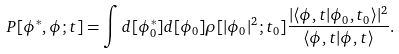<formula> <loc_0><loc_0><loc_500><loc_500>P [ \phi ^ { * } , \phi ; t ] = \int d [ \phi _ { 0 } ^ { * } ] d [ \phi _ { 0 } ] \rho [ | \phi _ { 0 } | ^ { 2 } ; t _ { 0 } ] \frac { | \langle \phi , t | \phi _ { 0 } , t _ { 0 } \rangle | ^ { 2 } } { \langle \phi , t | \phi , t \rangle } .</formula> 